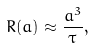Convert formula to latex. <formula><loc_0><loc_0><loc_500><loc_500>R ( a ) \approx \frac { a ^ { 3 } } { \tau } ,</formula> 